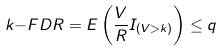<formula> <loc_0><loc_0><loc_500><loc_500>k { - F D R } = E \left ( { \frac { V } { R } } I _ { ( V > k ) } \right ) \leq q</formula> 